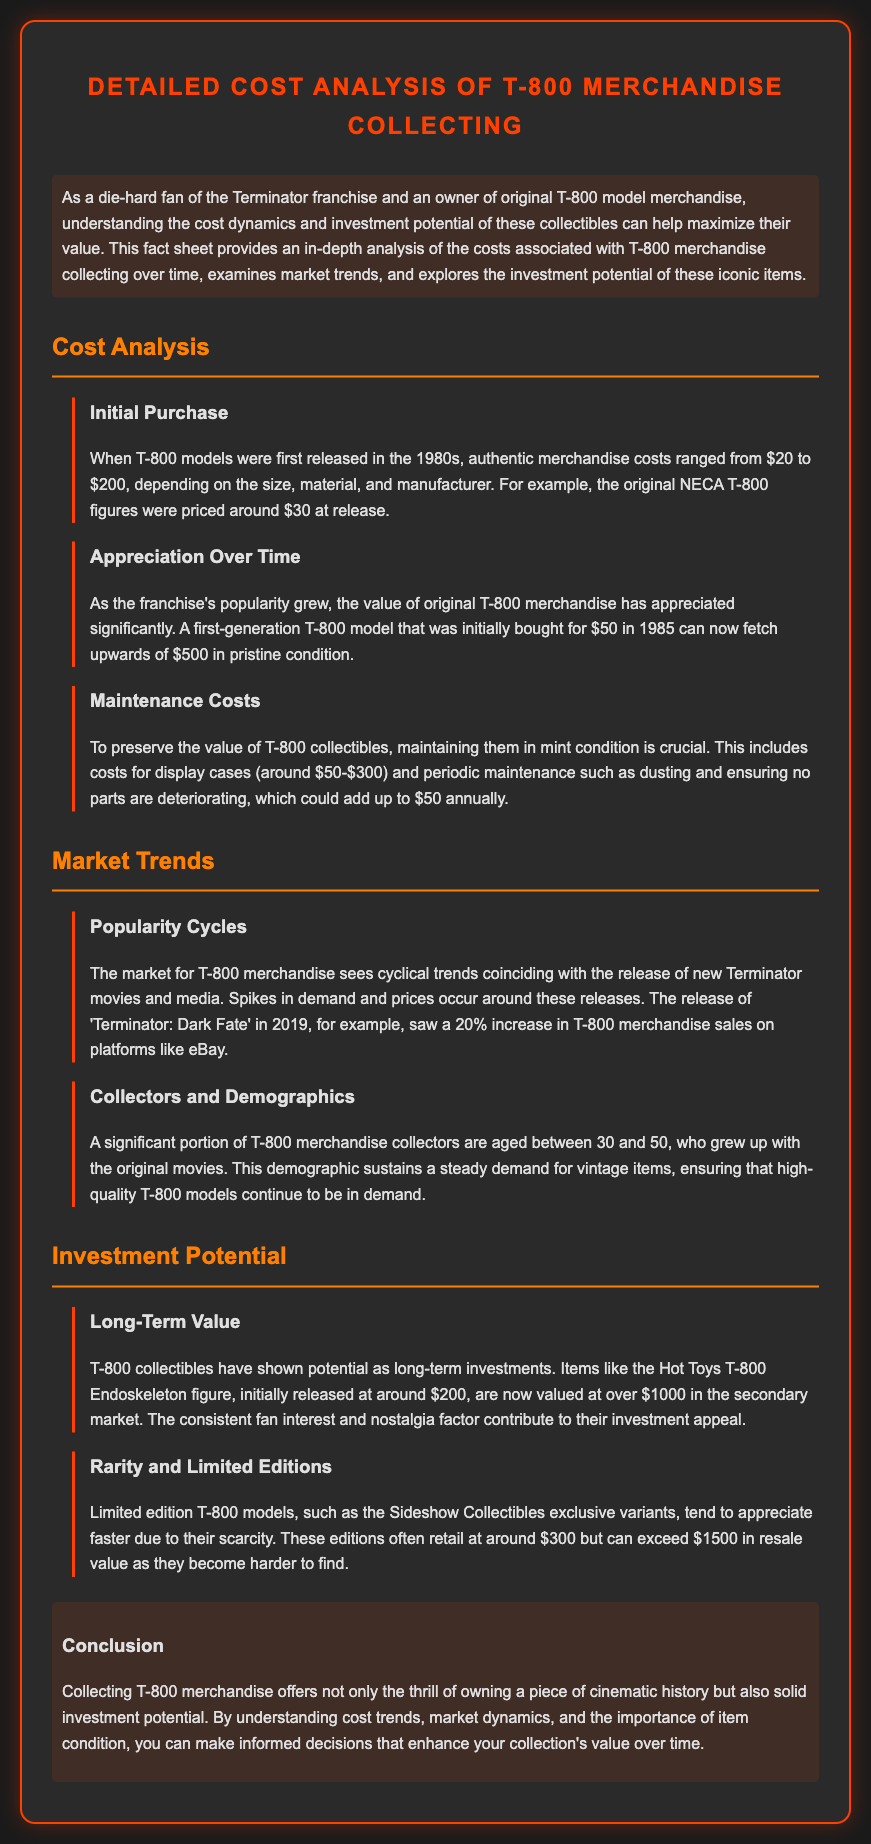What was the initial price range for T-800 models in the 1980s? The document states that initial merchandise costs ranged from $20 to $200.
Answer: $20 to $200 What was the price of the original NECA T-800 figures at release? The document mentions that original NECA T-800 figures were priced around $30 at release.
Answer: $30 How much has a first-generation T-800 model appreciated since 1985? According to the document, a model bought for $50 can now fetch upwards of $500.
Answer: Upwards of $500 What factors contribute to the maintenance costs for T-800 collectibles? The document outlines display cases and periodic maintenance, adding up to $50 annually.
Answer: Display cases and periodic maintenance What demographic primarily collects T-800 merchandise? The document indicates that a significant portion of collectors are aged between 30 and 50.
Answer: Aged between 30 and 50 What was the percentage increase in T-800 merchandise sales after 'Terminator: Dark Fate' release? The document notes a 20% increase in sales around the release of 'Terminator: Dark Fate'.
Answer: 20% What is the resale value range for limited edition T-800 models? According to the document, they can exceed $1500 in resale value.
Answer: Exceed $1500 How does the document categorize types of questions? The document categories types of questions include information retrieval, reasoning, and document-specific questions.
Answer: Information retrieval, reasoning, document-specific What key aspect is emphasized for preserving the value of T-800 collectibles? The document emphasizes maintaining them in mint condition.
Answer: Maintaining them in mint condition What is the current market value of the Hot Toys T-800 Endoskeleton figure? The document specifies that it is now valued at over $1000 in the secondary market.
Answer: Over $1000 